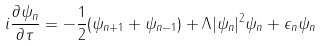Convert formula to latex. <formula><loc_0><loc_0><loc_500><loc_500>i \frac { \partial \psi _ { n } } { \partial \tau } = - \frac { 1 } { 2 } ( \psi _ { n + 1 } + \psi _ { n - 1 } ) + \Lambda | \psi _ { n } | ^ { 2 } \psi _ { n } + \epsilon _ { n } \psi _ { n }</formula> 